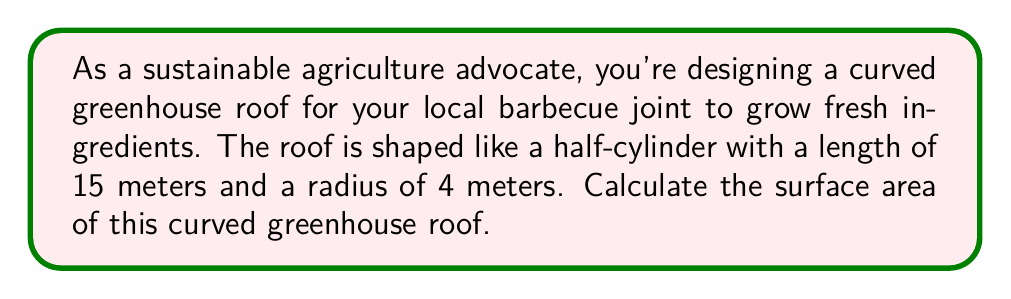What is the answer to this math problem? To solve this problem, we need to use the formula for the surface area of a cylinder, but only for half of the curved surface (since it's a half-cylinder) plus the area of the rectangular base.

1. The formula for the curved surface area of a full cylinder is:
   $$A_{curved} = 2\pi rh$$
   where $r$ is the radius and $h$ is the height (length in this case).

2. Since we only need half of the curved surface, we divide this by 2:
   $$A_{curved\_half} = \frac{1}{2} \cdot 2\pi rh = \pi rh$$

3. Substituting the given values:
   $$A_{curved\_half} = \pi \cdot 4 \cdot 15 = 60\pi \text{ m}^2$$

4. Now we need to add the rectangular base area:
   $$A_{base} = \text{length} \cdot \text{width} = 15 \cdot 8 = 120 \text{ m}^2$$

5. The total surface area is the sum of the curved half and the base:
   $$A_{total} = A_{curved\_half} + A_{base} = 60\pi + 120 \text{ m}^2$$

6. Simplifying:
   $$A_{total} = (60\pi + 120) \text{ m}^2 \approx 308.40 \text{ m}^2$$

[asy]
import geometry;

size(200);
real r = 4;
real h = 15;

path p = arc((0,0), r, 0, 180);
path q = arc((h,0), r, 0, 180);

draw(p -- (h,0) -- (h,2r) -- (0,2r) -- cycle);
draw(q);

draw((0,0)--(h,0), dashed);
draw((0,2r)--(h,2r), dashed);

label("15 m", (h/2,0), S);
label("8 m", (h,r), E);
label("r = 4 m", (0,r), W);
[/asy]
Answer: The surface area of the curved greenhouse roof is approximately 308.40 square meters. 